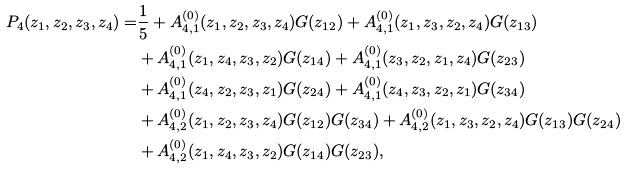<formula> <loc_0><loc_0><loc_500><loc_500>P _ { 4 } ( z _ { 1 } , z _ { 2 } , z _ { 3 } , z _ { 4 } ) = & \frac { 1 } { 5 } + A _ { 4 , 1 } ^ { ( 0 ) } ( z _ { 1 } , z _ { 2 } , z _ { 3 } , z _ { 4 } ) G ( z _ { 1 2 } ) + A _ { 4 , 1 } ^ { ( 0 ) } ( z _ { 1 } , z _ { 3 } , z _ { 2 } , z _ { 4 } ) G ( z _ { 1 3 } ) \\ & + A _ { 4 , 1 } ^ { ( 0 ) } ( z _ { 1 } , z _ { 4 } , z _ { 3 } , z _ { 2 } ) G ( z _ { 1 4 } ) + A _ { 4 , 1 } ^ { ( 0 ) } ( z _ { 3 } , z _ { 2 } , z _ { 1 } , z _ { 4 } ) G ( z _ { 2 3 } ) \\ & + A _ { 4 , 1 } ^ { ( 0 ) } ( z _ { 4 } , z _ { 2 } , z _ { 3 } , z _ { 1 } ) G ( z _ { 2 4 } ) + A _ { 4 , 1 } ^ { ( 0 ) } ( z _ { 4 } , z _ { 3 } , z _ { 2 } , z _ { 1 } ) G ( z _ { 3 4 } ) \\ & + A _ { 4 , 2 } ^ { ( 0 ) } ( z _ { 1 } , z _ { 2 } , z _ { 3 } , z _ { 4 } ) G ( z _ { 1 2 } ) G ( z _ { 3 4 } ) + A _ { 4 , 2 } ^ { ( 0 ) } ( z _ { 1 } , z _ { 3 } , z _ { 2 } , z _ { 4 } ) G ( z _ { 1 3 } ) G ( z _ { 2 4 } ) \\ & + A _ { 4 , 2 } ^ { ( 0 ) } ( z _ { 1 } , z _ { 4 } , z _ { 3 } , z _ { 2 } ) G ( z _ { 1 4 } ) G ( z _ { 2 3 } ) ,</formula> 